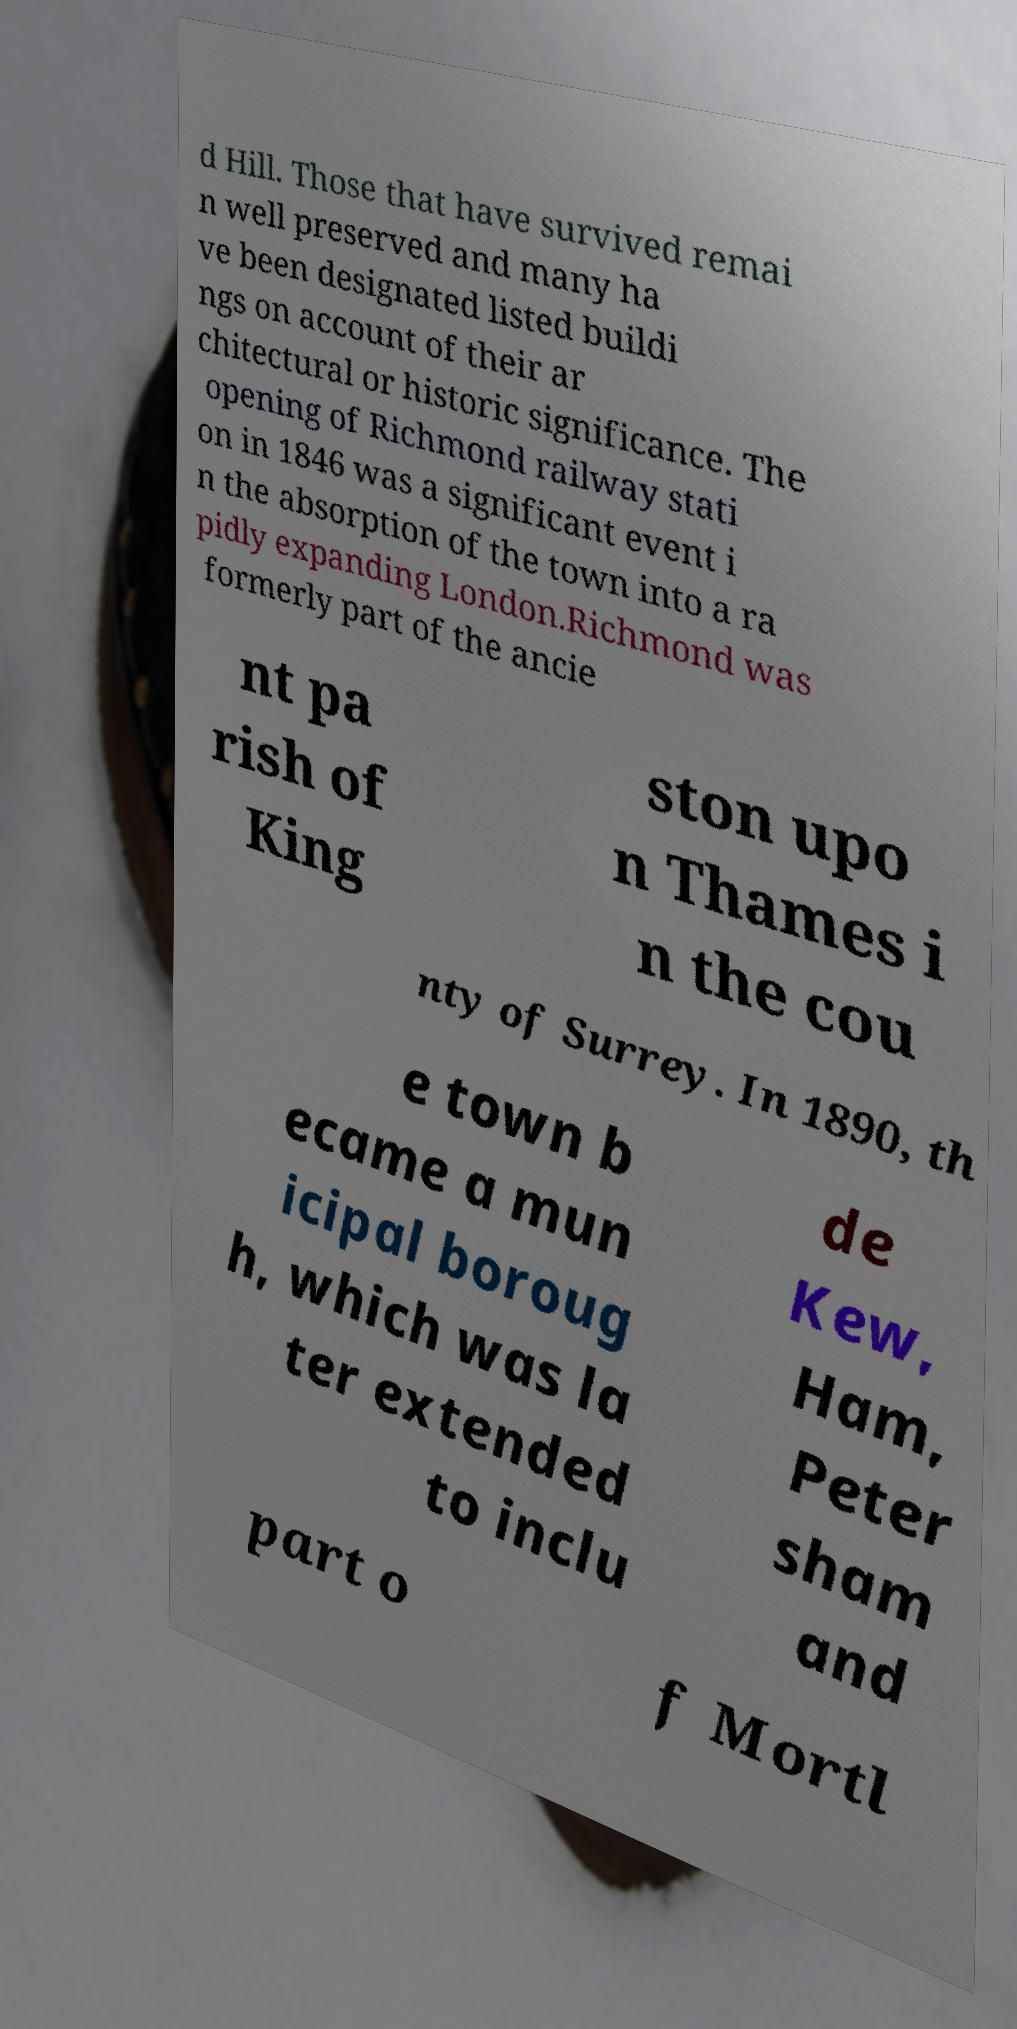Can you accurately transcribe the text from the provided image for me? d Hill. Those that have survived remai n well preserved and many ha ve been designated listed buildi ngs on account of their ar chitectural or historic significance. The opening of Richmond railway stati on in 1846 was a significant event i n the absorption of the town into a ra pidly expanding London.Richmond was formerly part of the ancie nt pa rish of King ston upo n Thames i n the cou nty of Surrey. In 1890, th e town b ecame a mun icipal boroug h, which was la ter extended to inclu de Kew, Ham, Peter sham and part o f Mortl 